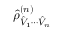Convert formula to latex. <formula><loc_0><loc_0><loc_500><loc_500>\hat { \rho } _ { \hat { V } _ { 1 } \cdots \hat { V } _ { n } } ^ { ( n ) }</formula> 